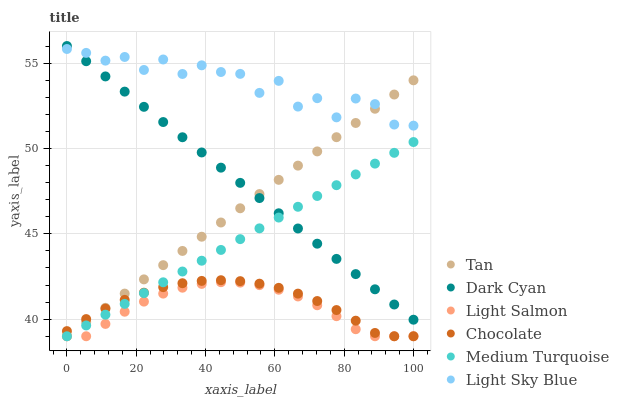Does Light Salmon have the minimum area under the curve?
Answer yes or no. Yes. Does Light Sky Blue have the maximum area under the curve?
Answer yes or no. Yes. Does Chocolate have the minimum area under the curve?
Answer yes or no. No. Does Chocolate have the maximum area under the curve?
Answer yes or no. No. Is Tan the smoothest?
Answer yes or no. Yes. Is Light Sky Blue the roughest?
Answer yes or no. Yes. Is Chocolate the smoothest?
Answer yes or no. No. Is Chocolate the roughest?
Answer yes or no. No. Does Light Salmon have the lowest value?
Answer yes or no. Yes. Does Light Sky Blue have the lowest value?
Answer yes or no. No. Does Dark Cyan have the highest value?
Answer yes or no. Yes. Does Chocolate have the highest value?
Answer yes or no. No. Is Light Salmon less than Light Sky Blue?
Answer yes or no. Yes. Is Dark Cyan greater than Light Salmon?
Answer yes or no. Yes. Does Tan intersect Chocolate?
Answer yes or no. Yes. Is Tan less than Chocolate?
Answer yes or no. No. Is Tan greater than Chocolate?
Answer yes or no. No. Does Light Salmon intersect Light Sky Blue?
Answer yes or no. No. 